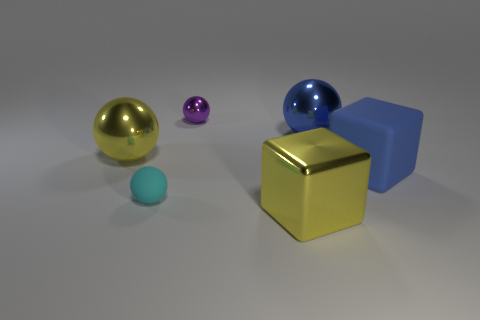Add 1 yellow metallic balls. How many objects exist? 7 Subtract all blue spheres. How many spheres are left? 3 Subtract all blue cubes. How many cubes are left? 1 Subtract 1 blocks. How many blocks are left? 1 Subtract 1 yellow spheres. How many objects are left? 5 Subtract all blocks. How many objects are left? 4 Subtract all green blocks. Subtract all gray cylinders. How many blocks are left? 2 Subtract all blue balls. How many red blocks are left? 0 Subtract all tiny metal balls. Subtract all small cyan spheres. How many objects are left? 4 Add 3 large blue blocks. How many large blue blocks are left? 4 